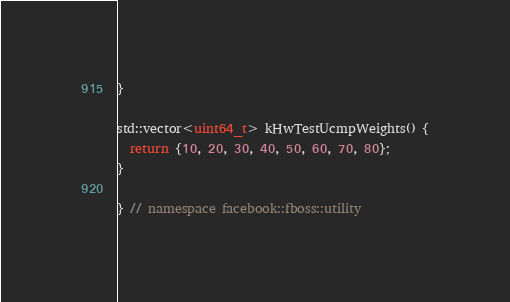<code> <loc_0><loc_0><loc_500><loc_500><_C++_>}

std::vector<uint64_t> kHwTestUcmpWeights() {
  return {10, 20, 30, 40, 50, 60, 70, 80};
}

} // namespace facebook::fboss::utility
</code> 